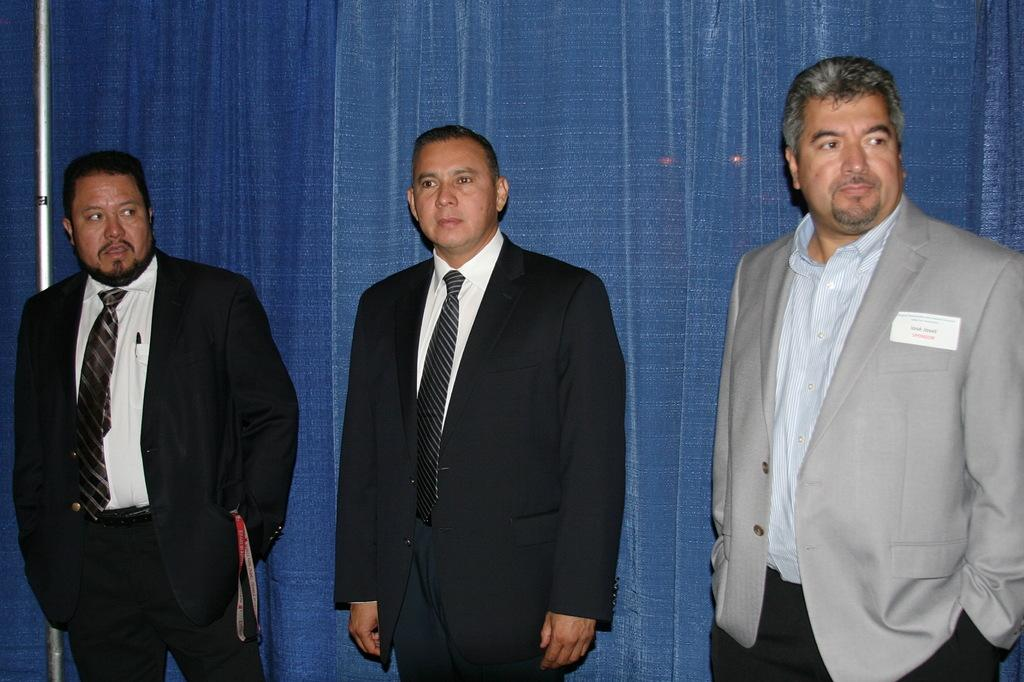How many people are in the image? There are persons standing in the image. What are the people wearing? The persons are wearing clothes. What can be seen on the left side of the image? There is a pole on the left side of the image. What is visible in the background of the image? There are curtains visible in the background of the image. Can you tell me how many ghosts are visible in the image? There are no ghosts present in the image; it features persons standing and wearing clothes, a pole on the left side, and curtains in the background. 